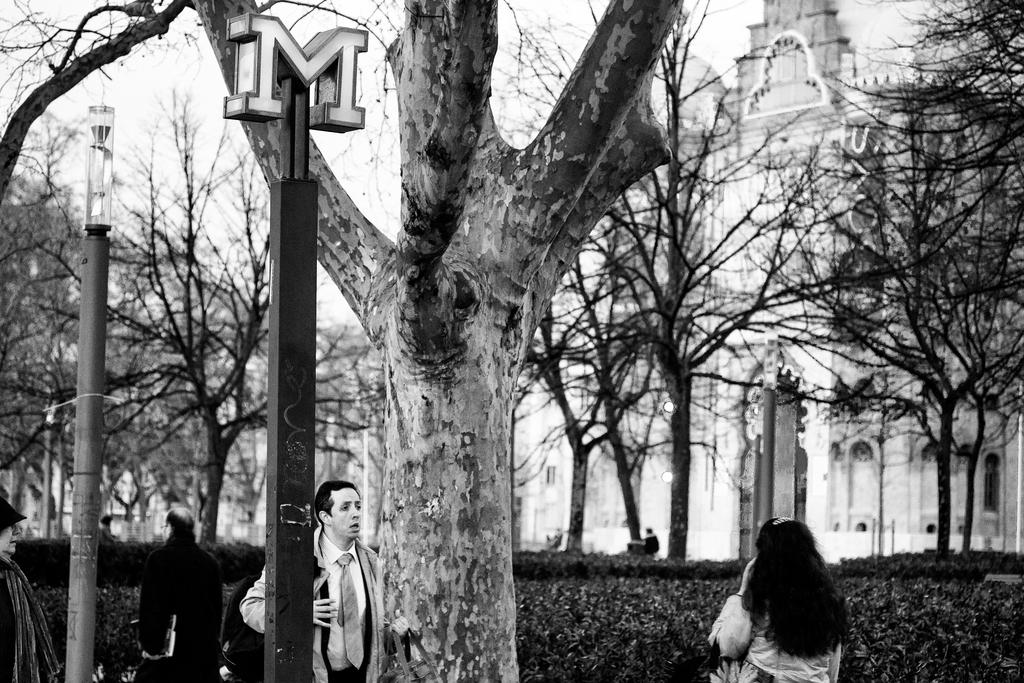What is located in the foreground of the image? There is a tree and poles in the foreground of the image. What are the people in the foreground of the image doing? There are persons walking in the foreground of the image. What can be seen in the background of the image? There are plants, a building, trees, and the sky visible in the background of the image. How many babies are expressing regret in the image? There are no babies or expressions of regret present in the image. What type of quilt is draped over the tree in the image? There is no quilt present in the image; it features a tree, poles, persons walking, plants, a building, trees, and the sky. 